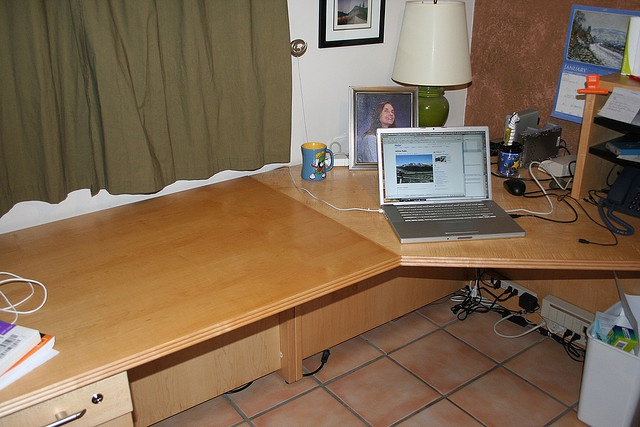Describe the objects in this image and their specific colors. I can see laptop in darkgreen, darkgray, gray, lightgray, and lightblue tones, book in darkgreen, lightgray, darkgray, and purple tones, book in darkgreen, lavender, salmon, red, and lightpink tones, cup in darkgreen, gray, and orange tones, and mouse in darkgreen, black, maroon, and gray tones in this image. 